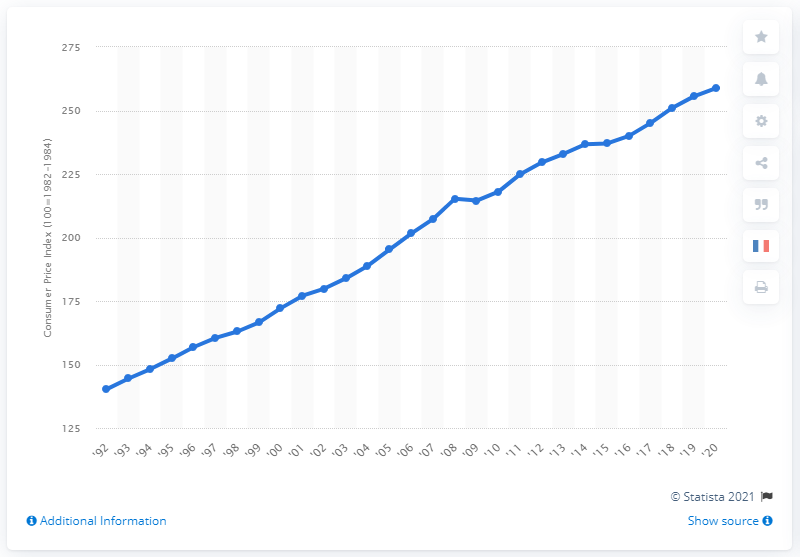List a handful of essential elements in this visual. The Consumer Price Index (CPI) in 2020 was 258.81. 